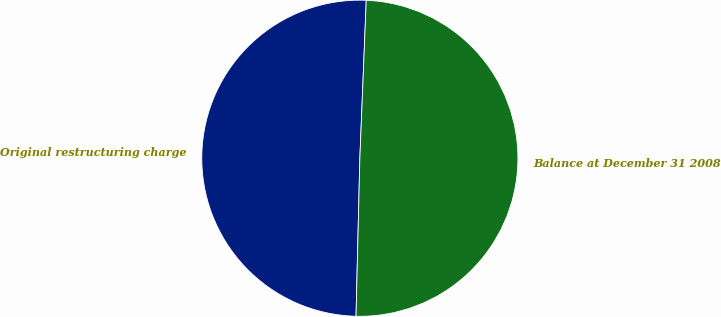Convert chart. <chart><loc_0><loc_0><loc_500><loc_500><pie_chart><fcel>Original restructuring charge<fcel>Balance at December 31 2008<nl><fcel>50.26%<fcel>49.74%<nl></chart> 